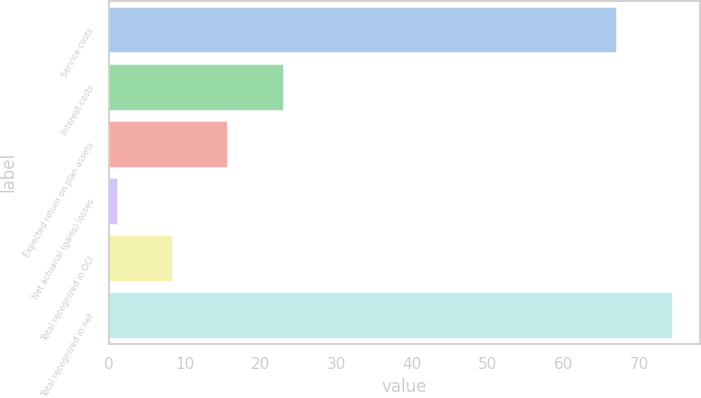<chart> <loc_0><loc_0><loc_500><loc_500><bar_chart><fcel>Service costs<fcel>Interest costs<fcel>Expected return on plan assets<fcel>Net actuarial (gains) losses<fcel>Total recognized in OCI<fcel>Total recognized in net<nl><fcel>67<fcel>22.9<fcel>15.6<fcel>1<fcel>8.3<fcel>74.3<nl></chart> 